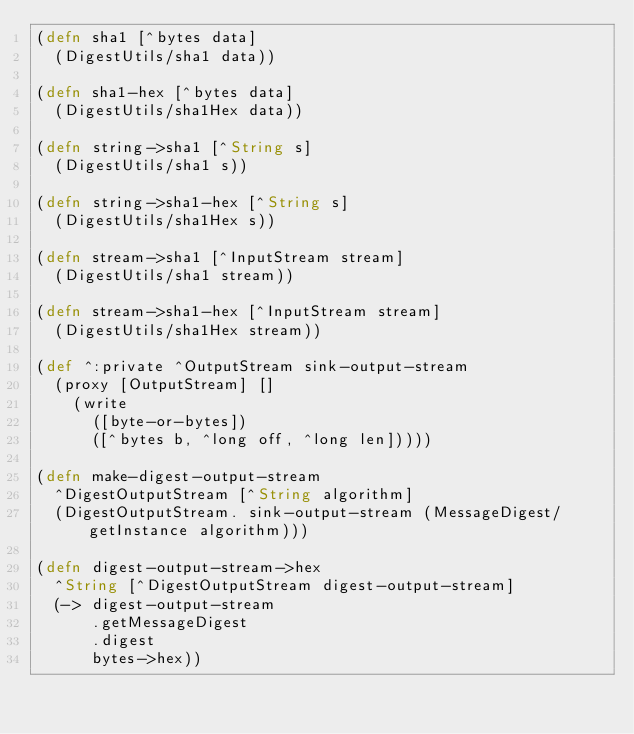Convert code to text. <code><loc_0><loc_0><loc_500><loc_500><_Clojure_>(defn sha1 [^bytes data]
  (DigestUtils/sha1 data))

(defn sha1-hex [^bytes data]
  (DigestUtils/sha1Hex data))

(defn string->sha1 [^String s]
  (DigestUtils/sha1 s))

(defn string->sha1-hex [^String s]
  (DigestUtils/sha1Hex s))

(defn stream->sha1 [^InputStream stream]
  (DigestUtils/sha1 stream))

(defn stream->sha1-hex [^InputStream stream]
  (DigestUtils/sha1Hex stream))

(def ^:private ^OutputStream sink-output-stream
  (proxy [OutputStream] []
    (write
      ([byte-or-bytes])
      ([^bytes b, ^long off, ^long len]))))

(defn make-digest-output-stream
  ^DigestOutputStream [^String algorithm]
  (DigestOutputStream. sink-output-stream (MessageDigest/getInstance algorithm)))

(defn digest-output-stream->hex
  ^String [^DigestOutputStream digest-output-stream]
  (-> digest-output-stream
      .getMessageDigest
      .digest
      bytes->hex))
</code> 